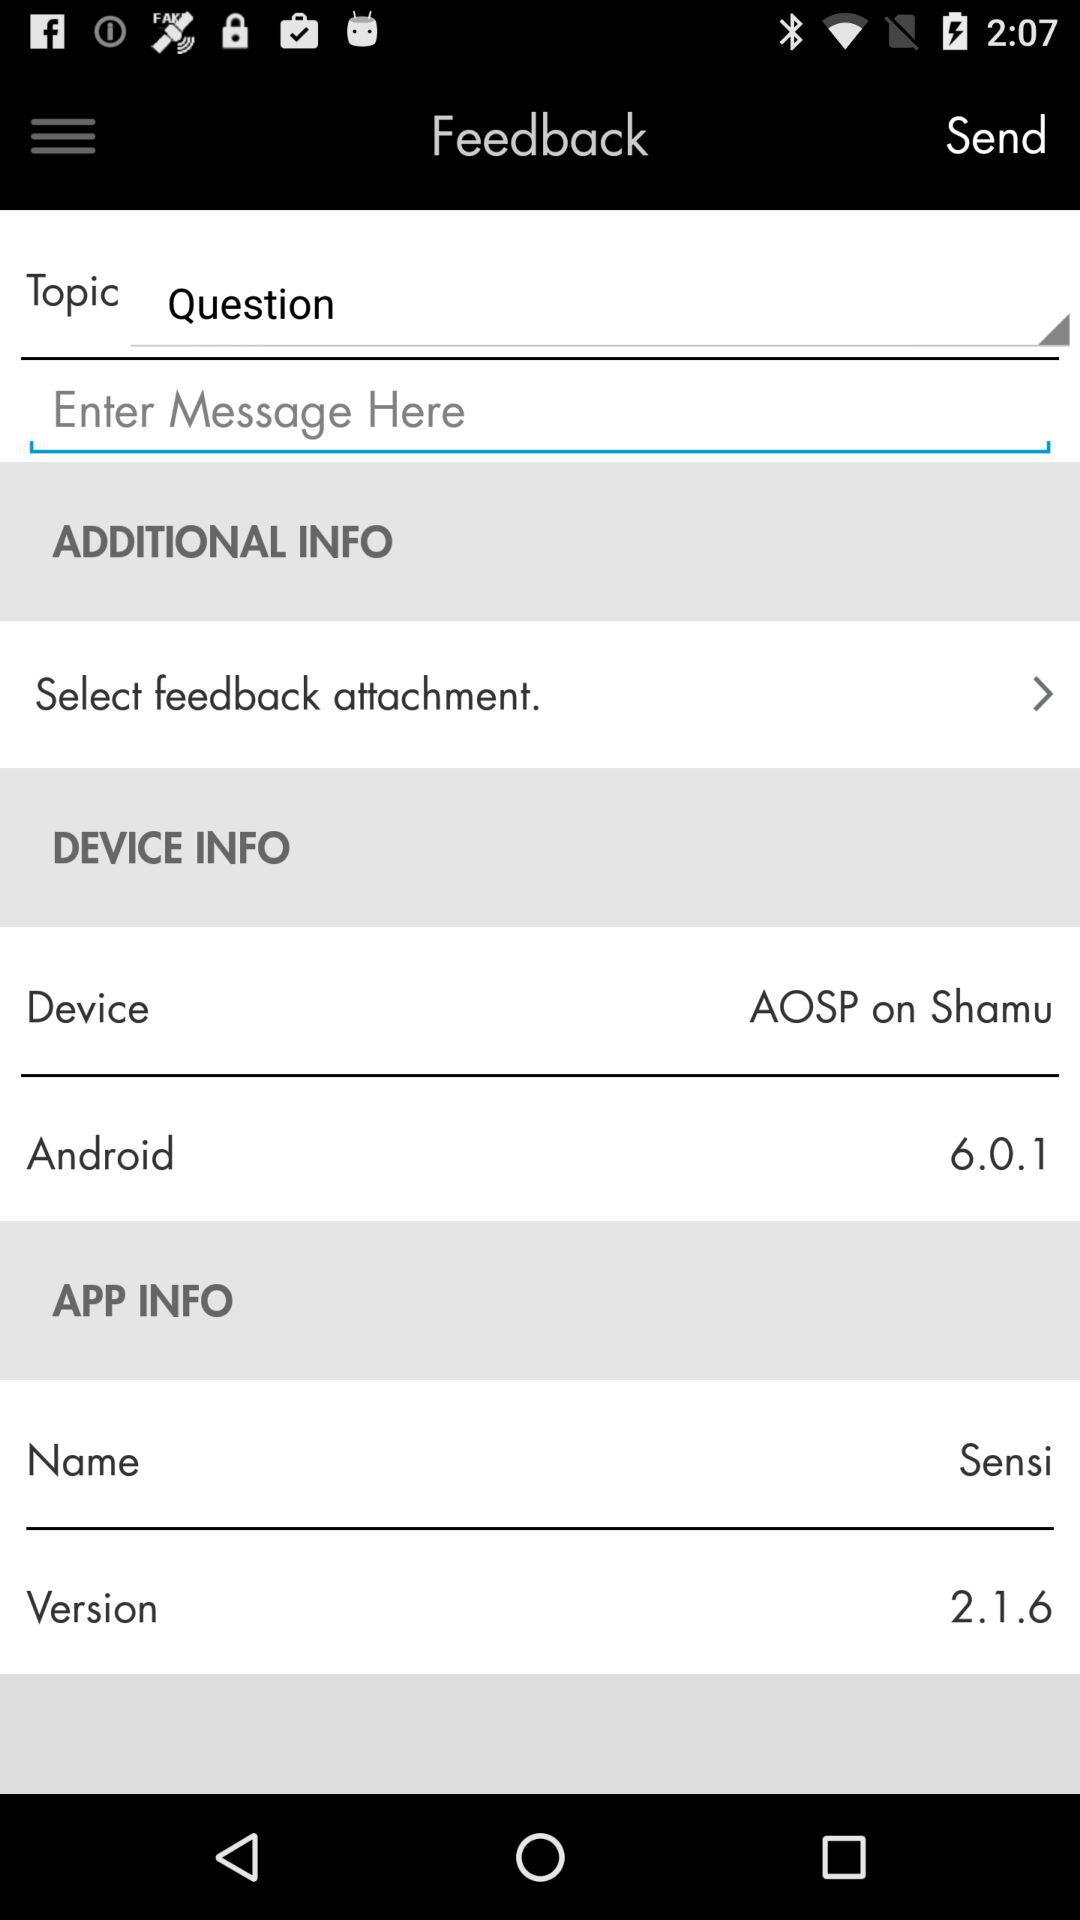What is the version of the device? The version of the device is 6.0.1. 